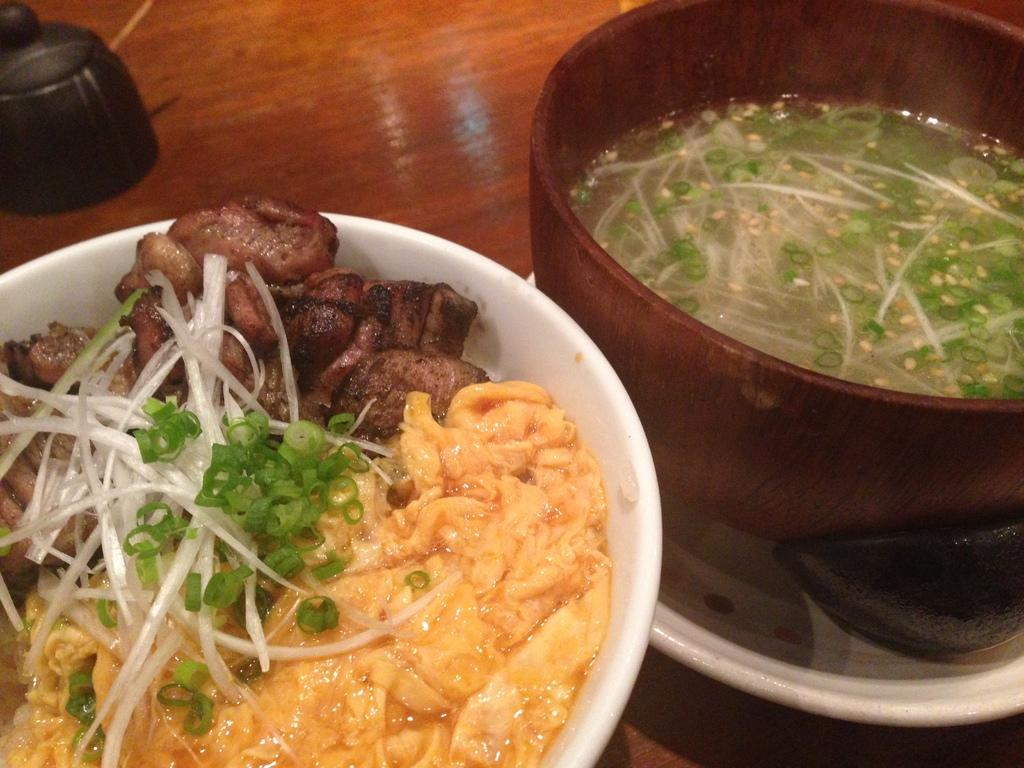What is placed in a bowl in the image? There is an eatable item placed in a bowl in the image. Can you describe the type of bowl on the table? There is a soup bowl on the table. How does the hen perform on the test in the image? There is no hen or test present in the image. 